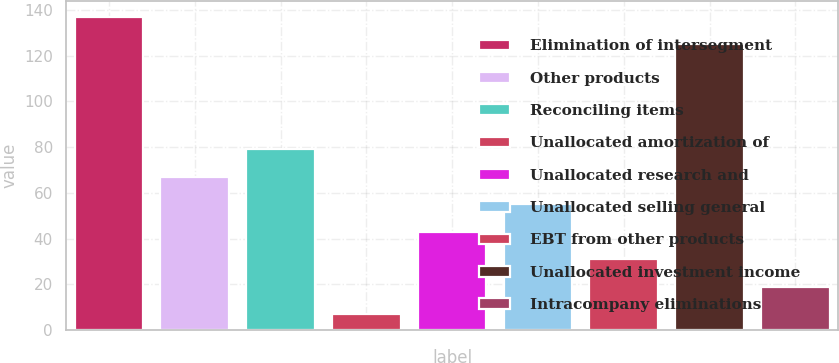Convert chart. <chart><loc_0><loc_0><loc_500><loc_500><bar_chart><fcel>Elimination of intersegment<fcel>Other products<fcel>Reconciling items<fcel>Unallocated amortization of<fcel>Unallocated research and<fcel>Unallocated selling general<fcel>EBT from other products<fcel>Unallocated investment income<fcel>Intracompany eliminations<nl><fcel>137<fcel>67<fcel>79<fcel>7<fcel>43<fcel>55<fcel>31<fcel>125<fcel>19<nl></chart> 